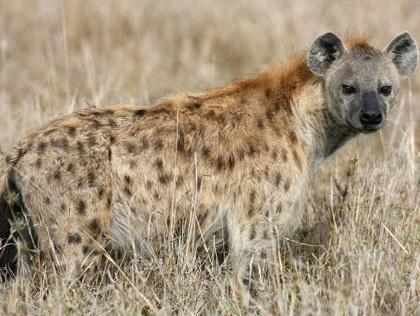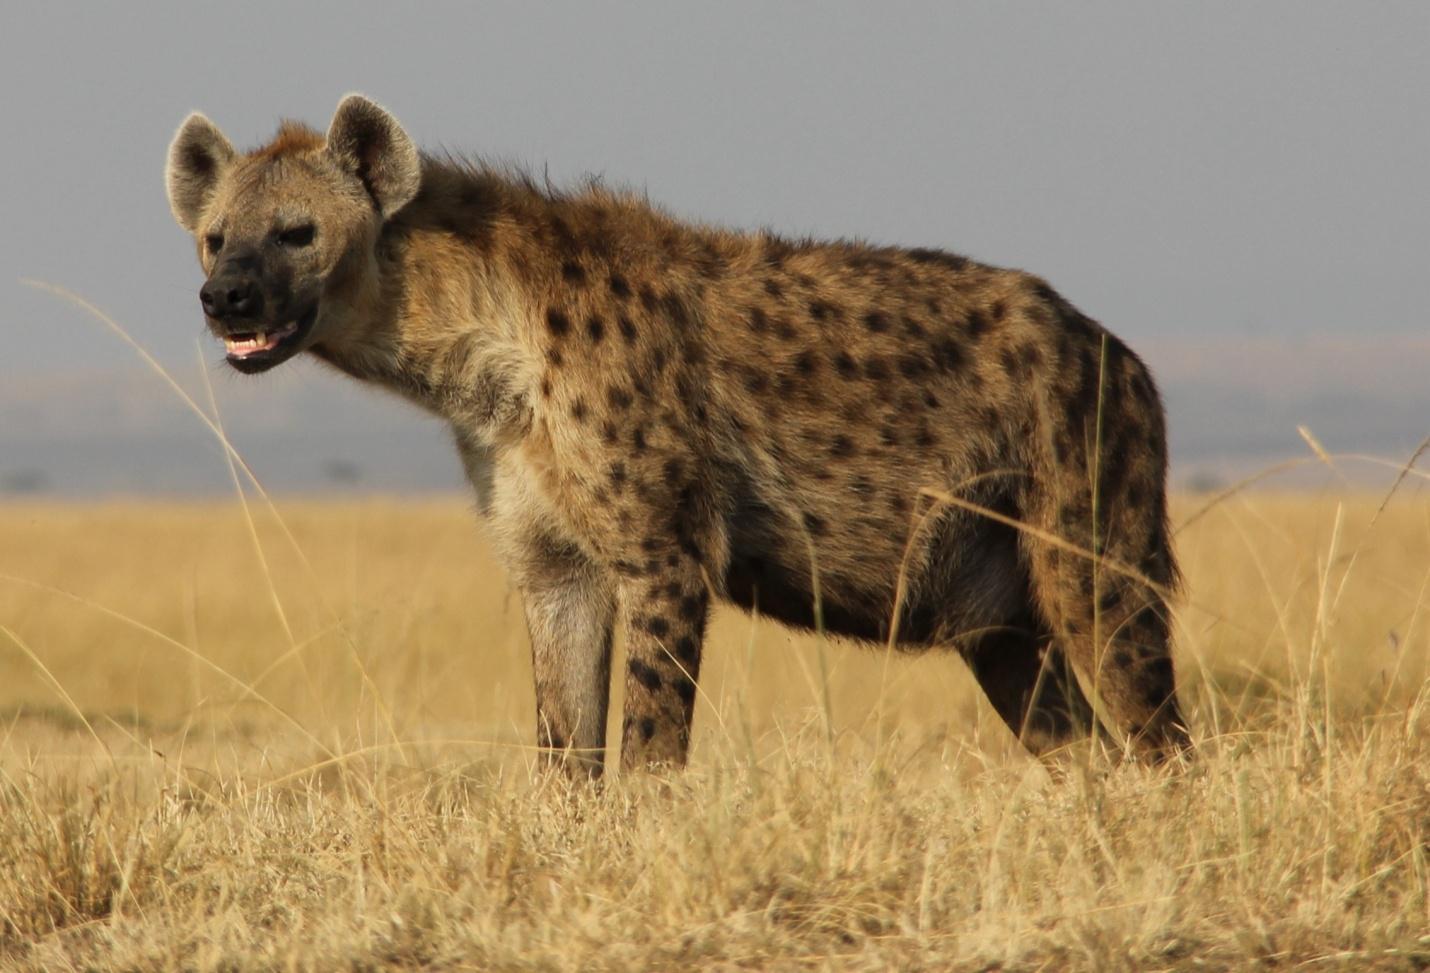The first image is the image on the left, the second image is the image on the right. Considering the images on both sides, is "At least one image shows a single hyena with its mouth partly open showing teeth." valid? Answer yes or no. Yes. 